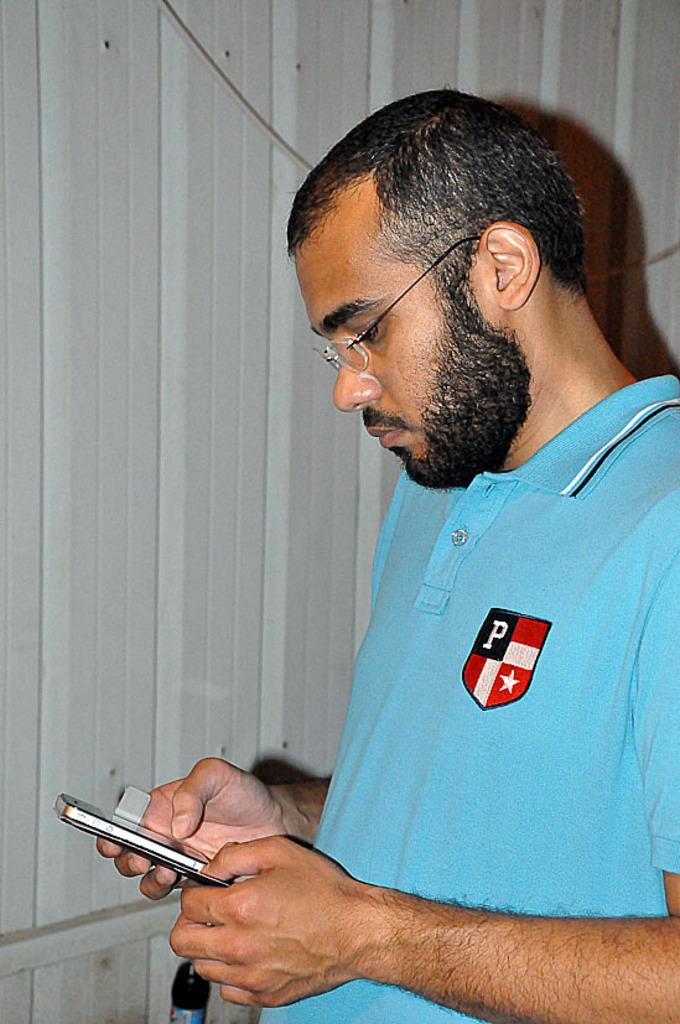What color is the t-shirt the man is wearing in the image? The man is wearing a blue t-shirt. What accessory is the man wearing in the image? The man is wearing spectacles. What object is the man holding in the image? The man is holding a mobile. What is the man doing with the mobile in the image? The man is looking at the mobile. What can be seen behind the man in the image? There is a wall behind the man. What type of jeans is the man wearing in the image? The facts provided do not mention the man wearing jeans, so we cannot determine the type of jeans he is wearing. 